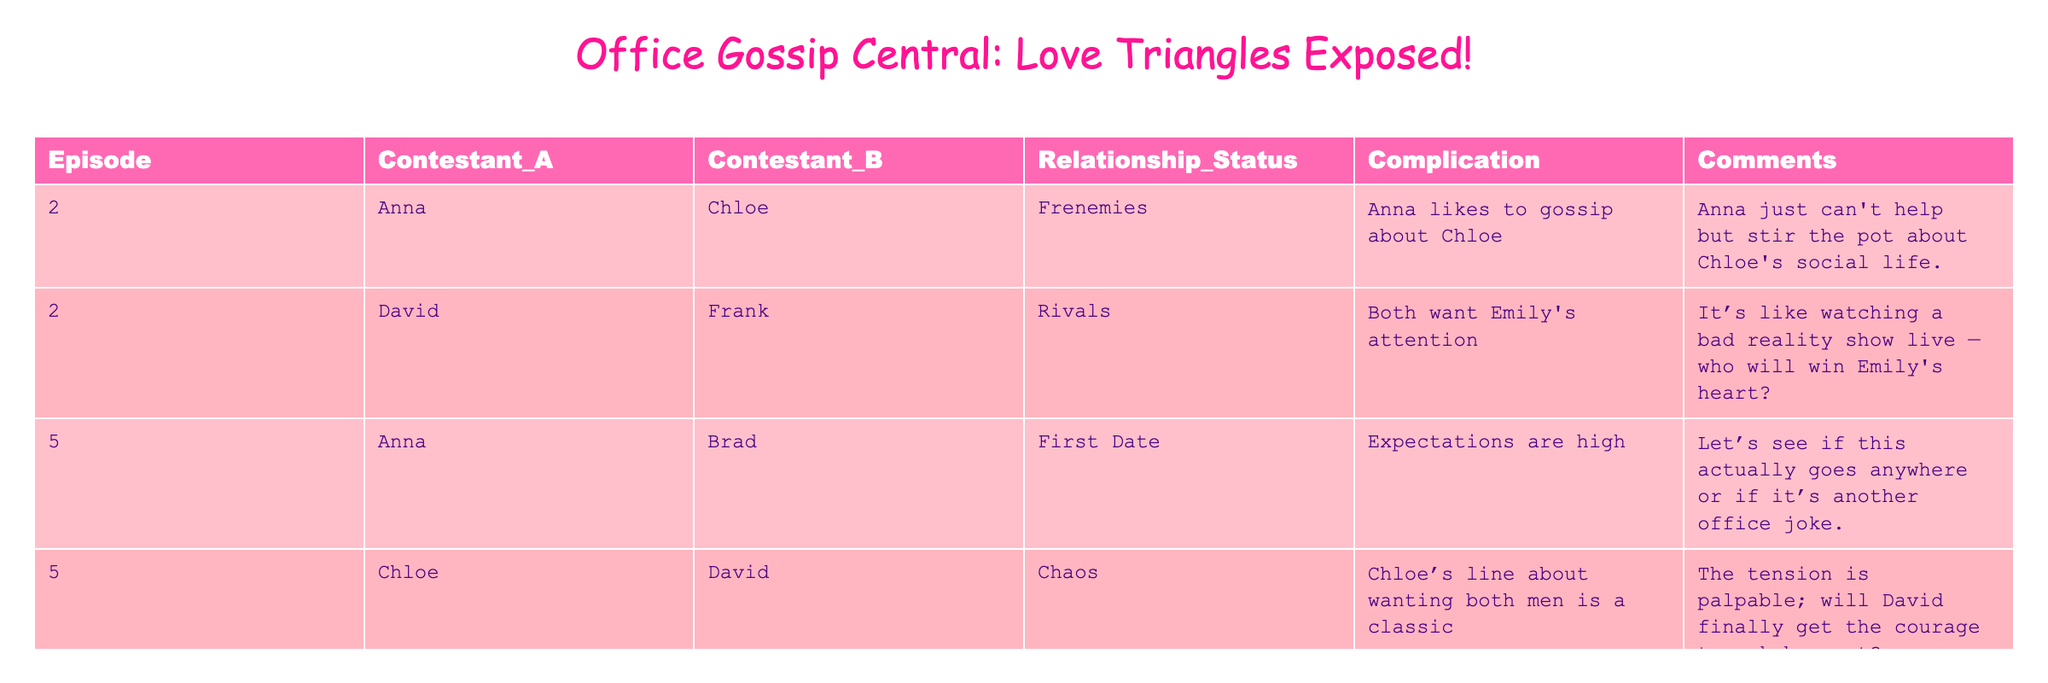What relationship status do Anna and Chloe have in Episode 2? Referring to Episode 2 in the table, Anna and Chloe are labeled as "Frenemies". This is clear from the specific row that mentions their status directly.
Answer: Frenemies How many cast members are involved in a love triangle in Episode 5? In Episode 5, there are three distinct relationships that suggest love triangles: Anna with Brad, Chloe with both David and potentially others, plus Emily’s connection withFrank. Counting these relationships indicates the presence of a triangle.
Answer: Three Did Emily and Frank have any complications in their relationship as per the table? Yes, it is noted in the table that Emily and Frank are "Exes Reunited", which is indeed a complication in their relationship. Hence the answer is yes.
Answer: Yes Is Chloe interested in David according to the table? In Episode 5, Chloe expresses a desire for both David and another male, which indicates her interest in David despite the chaos in their relationship. Thus, the statement is true.
Answer: True What is the main complication for Anna and Brad's first date? The table indicates that the complication for Anna and Brad is that "Expectations are high", suggesting that there is pressure surrounding their first date.
Answer: Expectations are high Which contestant is involved in the most complicated relationship dynamics across the episodes? Analyzing the table, Chloe emerges as the contestant with multiple relationships leading to complications: she’s involved with David and has connections with Anna and the other contestants. Hence, she has the most complicated dynamics.
Answer: Chloe How many contestants mentioned in Episode 5 are exes? In Episode 5, there are two contestants mentioned as exes — Emily and Frank, who are noted as "Exes Reunited". Thus, the count is straightforward from the table.
Answer: Two What is the relationship complication between David and Frank? According to the data, David and Frank are described as "Rivals" because both are vying for Emily's attention, which is clearly shown in Episode 2.
Answer: Rivals In which episode does Anna gossip about Chloe? The table states that Anna is gossiping about Chloe in Episode 2, which directly identifies when this occurrence takes place.
Answer: Episode 2 Which contestant has the least drama according to the table? Based on the descriptions in the table, Brad’s relationship appears straightforward (first date with Anna), while others have entanglements and complications. Thus, he seems to have the least drama.
Answer: Brad 